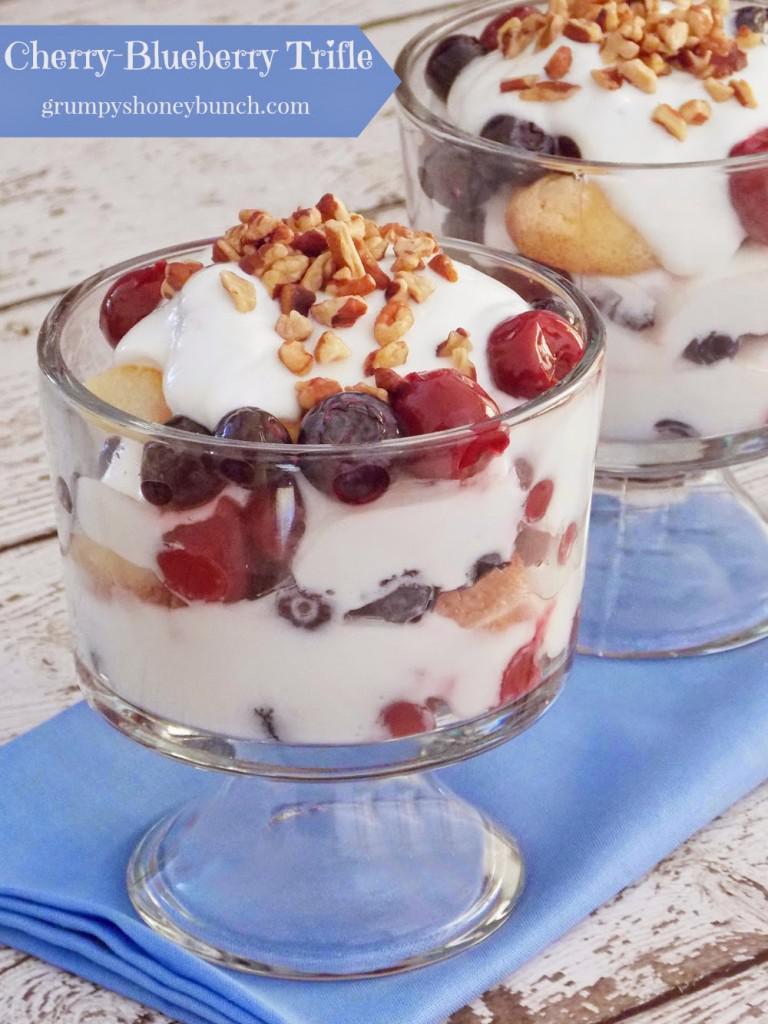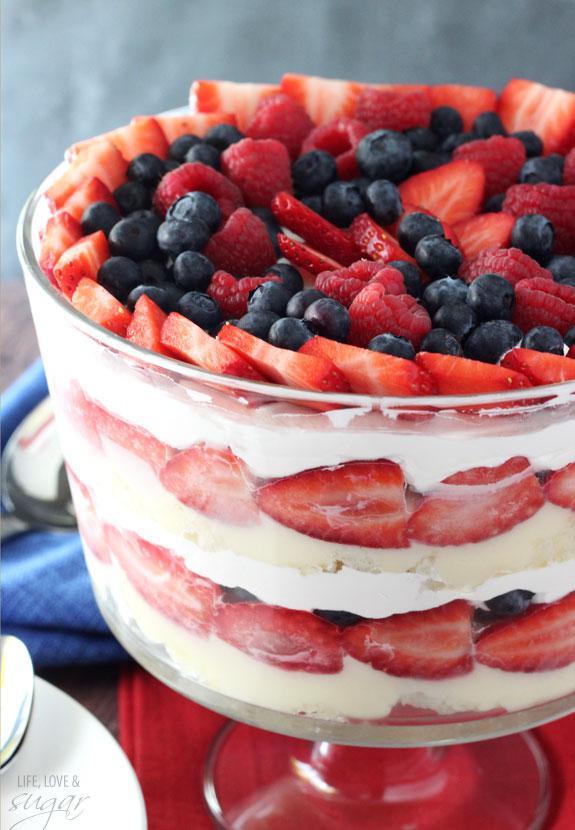The first image is the image on the left, the second image is the image on the right. Assess this claim about the two images: "There is exactly one container in the image on the right.". Correct or not? Answer yes or no. Yes. 